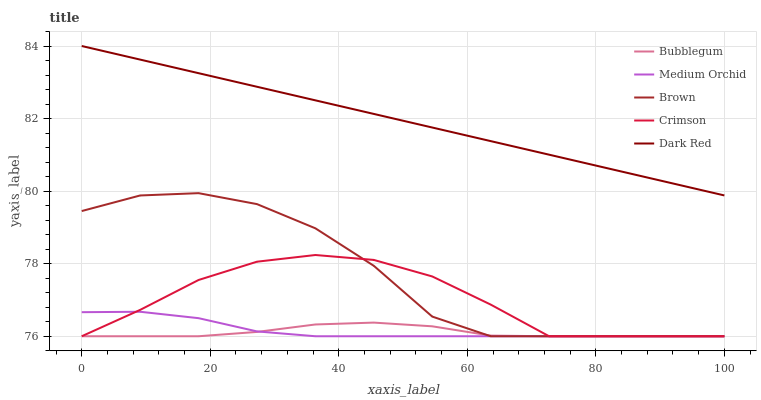Does Bubblegum have the minimum area under the curve?
Answer yes or no. Yes. Does Dark Red have the maximum area under the curve?
Answer yes or no. Yes. Does Brown have the minimum area under the curve?
Answer yes or no. No. Does Brown have the maximum area under the curve?
Answer yes or no. No. Is Dark Red the smoothest?
Answer yes or no. Yes. Is Brown the roughest?
Answer yes or no. Yes. Is Medium Orchid the smoothest?
Answer yes or no. No. Is Medium Orchid the roughest?
Answer yes or no. No. Does Crimson have the lowest value?
Answer yes or no. Yes. Does Dark Red have the lowest value?
Answer yes or no. No. Does Dark Red have the highest value?
Answer yes or no. Yes. Does Brown have the highest value?
Answer yes or no. No. Is Bubblegum less than Dark Red?
Answer yes or no. Yes. Is Dark Red greater than Medium Orchid?
Answer yes or no. Yes. Does Medium Orchid intersect Bubblegum?
Answer yes or no. Yes. Is Medium Orchid less than Bubblegum?
Answer yes or no. No. Is Medium Orchid greater than Bubblegum?
Answer yes or no. No. Does Bubblegum intersect Dark Red?
Answer yes or no. No. 